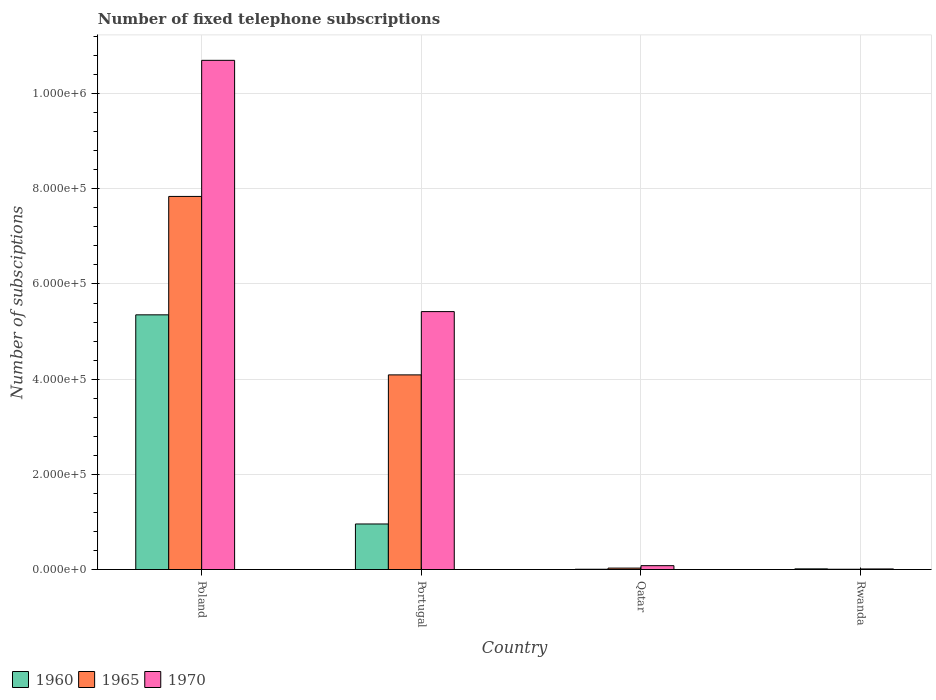How many different coloured bars are there?
Provide a succinct answer. 3. How many groups of bars are there?
Make the answer very short. 4. Are the number of bars on each tick of the X-axis equal?
Offer a terse response. Yes. How many bars are there on the 3rd tick from the right?
Provide a short and direct response. 3. What is the label of the 3rd group of bars from the left?
Your answer should be very brief. Qatar. In how many cases, is the number of bars for a given country not equal to the number of legend labels?
Provide a short and direct response. 0. What is the number of fixed telephone subscriptions in 1960 in Rwanda?
Offer a very short reply. 1366. Across all countries, what is the maximum number of fixed telephone subscriptions in 1960?
Make the answer very short. 5.35e+05. Across all countries, what is the minimum number of fixed telephone subscriptions in 1960?
Your answer should be compact. 600. In which country was the number of fixed telephone subscriptions in 1960 maximum?
Offer a very short reply. Poland. In which country was the number of fixed telephone subscriptions in 1960 minimum?
Offer a terse response. Qatar. What is the total number of fixed telephone subscriptions in 1960 in the graph?
Provide a short and direct response. 6.33e+05. What is the difference between the number of fixed telephone subscriptions in 1960 in Poland and that in Portugal?
Provide a succinct answer. 4.40e+05. What is the difference between the number of fixed telephone subscriptions in 1965 in Portugal and the number of fixed telephone subscriptions in 1960 in Rwanda?
Your response must be concise. 4.08e+05. What is the average number of fixed telephone subscriptions in 1970 per country?
Your answer should be very brief. 4.05e+05. What is the difference between the number of fixed telephone subscriptions of/in 1960 and number of fixed telephone subscriptions of/in 1965 in Qatar?
Your response must be concise. -2400. In how many countries, is the number of fixed telephone subscriptions in 1960 greater than 480000?
Provide a succinct answer. 1. What is the ratio of the number of fixed telephone subscriptions in 1965 in Portugal to that in Rwanda?
Ensure brevity in your answer.  681.67. Is the number of fixed telephone subscriptions in 1965 in Portugal less than that in Rwanda?
Provide a succinct answer. No. Is the difference between the number of fixed telephone subscriptions in 1960 in Poland and Portugal greater than the difference between the number of fixed telephone subscriptions in 1965 in Poland and Portugal?
Give a very brief answer. Yes. What is the difference between the highest and the second highest number of fixed telephone subscriptions in 1960?
Provide a short and direct response. -4.40e+05. What is the difference between the highest and the lowest number of fixed telephone subscriptions in 1965?
Your answer should be compact. 7.83e+05. What does the 1st bar from the left in Portugal represents?
Offer a very short reply. 1960. What does the 3rd bar from the right in Poland represents?
Give a very brief answer. 1960. How many bars are there?
Offer a very short reply. 12. Are all the bars in the graph horizontal?
Keep it short and to the point. No. How many countries are there in the graph?
Ensure brevity in your answer.  4. What is the difference between two consecutive major ticks on the Y-axis?
Provide a short and direct response. 2.00e+05. Does the graph contain grids?
Your response must be concise. Yes. How many legend labels are there?
Give a very brief answer. 3. What is the title of the graph?
Provide a short and direct response. Number of fixed telephone subscriptions. Does "1985" appear as one of the legend labels in the graph?
Your answer should be very brief. No. What is the label or title of the X-axis?
Your answer should be compact. Country. What is the label or title of the Y-axis?
Ensure brevity in your answer.  Number of subsciptions. What is the Number of subsciptions of 1960 in Poland?
Offer a very short reply. 5.35e+05. What is the Number of subsciptions in 1965 in Poland?
Offer a terse response. 7.84e+05. What is the Number of subsciptions of 1970 in Poland?
Your answer should be very brief. 1.07e+06. What is the Number of subsciptions of 1960 in Portugal?
Provide a succinct answer. 9.57e+04. What is the Number of subsciptions in 1965 in Portugal?
Give a very brief answer. 4.09e+05. What is the Number of subsciptions of 1970 in Portugal?
Give a very brief answer. 5.42e+05. What is the Number of subsciptions of 1960 in Qatar?
Your response must be concise. 600. What is the Number of subsciptions in 1965 in Qatar?
Provide a short and direct response. 3000. What is the Number of subsciptions in 1970 in Qatar?
Ensure brevity in your answer.  8100. What is the Number of subsciptions in 1960 in Rwanda?
Make the answer very short. 1366. What is the Number of subsciptions of 1965 in Rwanda?
Provide a short and direct response. 600. What is the Number of subsciptions of 1970 in Rwanda?
Your response must be concise. 1200. Across all countries, what is the maximum Number of subsciptions of 1960?
Your answer should be compact. 5.35e+05. Across all countries, what is the maximum Number of subsciptions of 1965?
Give a very brief answer. 7.84e+05. Across all countries, what is the maximum Number of subsciptions of 1970?
Your answer should be compact. 1.07e+06. Across all countries, what is the minimum Number of subsciptions in 1960?
Provide a short and direct response. 600. Across all countries, what is the minimum Number of subsciptions in 1965?
Provide a succinct answer. 600. Across all countries, what is the minimum Number of subsciptions in 1970?
Make the answer very short. 1200. What is the total Number of subsciptions in 1960 in the graph?
Your answer should be very brief. 6.33e+05. What is the total Number of subsciptions in 1965 in the graph?
Offer a terse response. 1.20e+06. What is the total Number of subsciptions in 1970 in the graph?
Your response must be concise. 1.62e+06. What is the difference between the Number of subsciptions in 1960 in Poland and that in Portugal?
Provide a short and direct response. 4.40e+05. What is the difference between the Number of subsciptions in 1965 in Poland and that in Portugal?
Your answer should be compact. 3.75e+05. What is the difference between the Number of subsciptions of 1970 in Poland and that in Portugal?
Your answer should be very brief. 5.28e+05. What is the difference between the Number of subsciptions of 1960 in Poland and that in Qatar?
Provide a short and direct response. 5.35e+05. What is the difference between the Number of subsciptions in 1965 in Poland and that in Qatar?
Your response must be concise. 7.81e+05. What is the difference between the Number of subsciptions in 1970 in Poland and that in Qatar?
Ensure brevity in your answer.  1.06e+06. What is the difference between the Number of subsciptions in 1960 in Poland and that in Rwanda?
Offer a terse response. 5.34e+05. What is the difference between the Number of subsciptions in 1965 in Poland and that in Rwanda?
Offer a terse response. 7.83e+05. What is the difference between the Number of subsciptions of 1970 in Poland and that in Rwanda?
Offer a terse response. 1.07e+06. What is the difference between the Number of subsciptions of 1960 in Portugal and that in Qatar?
Provide a succinct answer. 9.51e+04. What is the difference between the Number of subsciptions in 1965 in Portugal and that in Qatar?
Offer a terse response. 4.06e+05. What is the difference between the Number of subsciptions of 1970 in Portugal and that in Qatar?
Offer a very short reply. 5.34e+05. What is the difference between the Number of subsciptions in 1960 in Portugal and that in Rwanda?
Your response must be concise. 9.43e+04. What is the difference between the Number of subsciptions of 1965 in Portugal and that in Rwanda?
Make the answer very short. 4.08e+05. What is the difference between the Number of subsciptions in 1970 in Portugal and that in Rwanda?
Offer a very short reply. 5.41e+05. What is the difference between the Number of subsciptions in 1960 in Qatar and that in Rwanda?
Give a very brief answer. -766. What is the difference between the Number of subsciptions in 1965 in Qatar and that in Rwanda?
Keep it short and to the point. 2400. What is the difference between the Number of subsciptions in 1970 in Qatar and that in Rwanda?
Your response must be concise. 6900. What is the difference between the Number of subsciptions in 1960 in Poland and the Number of subsciptions in 1965 in Portugal?
Provide a short and direct response. 1.26e+05. What is the difference between the Number of subsciptions in 1960 in Poland and the Number of subsciptions in 1970 in Portugal?
Your answer should be very brief. -6798. What is the difference between the Number of subsciptions in 1965 in Poland and the Number of subsciptions in 1970 in Portugal?
Provide a succinct answer. 2.42e+05. What is the difference between the Number of subsciptions of 1960 in Poland and the Number of subsciptions of 1965 in Qatar?
Your answer should be very brief. 5.32e+05. What is the difference between the Number of subsciptions in 1960 in Poland and the Number of subsciptions in 1970 in Qatar?
Offer a terse response. 5.27e+05. What is the difference between the Number of subsciptions in 1965 in Poland and the Number of subsciptions in 1970 in Qatar?
Your answer should be compact. 7.76e+05. What is the difference between the Number of subsciptions of 1960 in Poland and the Number of subsciptions of 1965 in Rwanda?
Give a very brief answer. 5.35e+05. What is the difference between the Number of subsciptions in 1960 in Poland and the Number of subsciptions in 1970 in Rwanda?
Your response must be concise. 5.34e+05. What is the difference between the Number of subsciptions in 1965 in Poland and the Number of subsciptions in 1970 in Rwanda?
Keep it short and to the point. 7.83e+05. What is the difference between the Number of subsciptions of 1960 in Portugal and the Number of subsciptions of 1965 in Qatar?
Your response must be concise. 9.27e+04. What is the difference between the Number of subsciptions in 1960 in Portugal and the Number of subsciptions in 1970 in Qatar?
Your answer should be very brief. 8.76e+04. What is the difference between the Number of subsciptions of 1965 in Portugal and the Number of subsciptions of 1970 in Qatar?
Provide a succinct answer. 4.01e+05. What is the difference between the Number of subsciptions of 1960 in Portugal and the Number of subsciptions of 1965 in Rwanda?
Make the answer very short. 9.51e+04. What is the difference between the Number of subsciptions in 1960 in Portugal and the Number of subsciptions in 1970 in Rwanda?
Ensure brevity in your answer.  9.45e+04. What is the difference between the Number of subsciptions in 1965 in Portugal and the Number of subsciptions in 1970 in Rwanda?
Your response must be concise. 4.08e+05. What is the difference between the Number of subsciptions of 1960 in Qatar and the Number of subsciptions of 1970 in Rwanda?
Your response must be concise. -600. What is the difference between the Number of subsciptions of 1965 in Qatar and the Number of subsciptions of 1970 in Rwanda?
Your response must be concise. 1800. What is the average Number of subsciptions of 1960 per country?
Offer a terse response. 1.58e+05. What is the average Number of subsciptions of 1965 per country?
Your answer should be compact. 2.99e+05. What is the average Number of subsciptions in 1970 per country?
Make the answer very short. 4.05e+05. What is the difference between the Number of subsciptions in 1960 and Number of subsciptions in 1965 in Poland?
Your answer should be very brief. -2.49e+05. What is the difference between the Number of subsciptions in 1960 and Number of subsciptions in 1970 in Poland?
Provide a succinct answer. -5.35e+05. What is the difference between the Number of subsciptions of 1965 and Number of subsciptions of 1970 in Poland?
Offer a terse response. -2.86e+05. What is the difference between the Number of subsciptions in 1960 and Number of subsciptions in 1965 in Portugal?
Offer a very short reply. -3.13e+05. What is the difference between the Number of subsciptions in 1960 and Number of subsciptions in 1970 in Portugal?
Keep it short and to the point. -4.46e+05. What is the difference between the Number of subsciptions of 1965 and Number of subsciptions of 1970 in Portugal?
Offer a terse response. -1.33e+05. What is the difference between the Number of subsciptions of 1960 and Number of subsciptions of 1965 in Qatar?
Offer a very short reply. -2400. What is the difference between the Number of subsciptions of 1960 and Number of subsciptions of 1970 in Qatar?
Make the answer very short. -7500. What is the difference between the Number of subsciptions in 1965 and Number of subsciptions in 1970 in Qatar?
Give a very brief answer. -5100. What is the difference between the Number of subsciptions of 1960 and Number of subsciptions of 1965 in Rwanda?
Provide a succinct answer. 766. What is the difference between the Number of subsciptions of 1960 and Number of subsciptions of 1970 in Rwanda?
Your answer should be compact. 166. What is the difference between the Number of subsciptions of 1965 and Number of subsciptions of 1970 in Rwanda?
Make the answer very short. -600. What is the ratio of the Number of subsciptions in 1960 in Poland to that in Portugal?
Your answer should be very brief. 5.59. What is the ratio of the Number of subsciptions in 1965 in Poland to that in Portugal?
Offer a terse response. 1.92. What is the ratio of the Number of subsciptions in 1970 in Poland to that in Portugal?
Make the answer very short. 1.97. What is the ratio of the Number of subsciptions in 1960 in Poland to that in Qatar?
Your answer should be very brief. 892. What is the ratio of the Number of subsciptions in 1965 in Poland to that in Qatar?
Provide a short and direct response. 261.33. What is the ratio of the Number of subsciptions in 1970 in Poland to that in Qatar?
Make the answer very short. 132.1. What is the ratio of the Number of subsciptions in 1960 in Poland to that in Rwanda?
Ensure brevity in your answer.  391.8. What is the ratio of the Number of subsciptions of 1965 in Poland to that in Rwanda?
Provide a succinct answer. 1306.67. What is the ratio of the Number of subsciptions in 1970 in Poland to that in Rwanda?
Ensure brevity in your answer.  891.67. What is the ratio of the Number of subsciptions in 1960 in Portugal to that in Qatar?
Provide a succinct answer. 159.5. What is the ratio of the Number of subsciptions of 1965 in Portugal to that in Qatar?
Your answer should be compact. 136.33. What is the ratio of the Number of subsciptions of 1970 in Portugal to that in Qatar?
Make the answer very short. 66.91. What is the ratio of the Number of subsciptions of 1960 in Portugal to that in Rwanda?
Provide a short and direct response. 70.06. What is the ratio of the Number of subsciptions of 1965 in Portugal to that in Rwanda?
Ensure brevity in your answer.  681.67. What is the ratio of the Number of subsciptions of 1970 in Portugal to that in Rwanda?
Provide a succinct answer. 451.67. What is the ratio of the Number of subsciptions of 1960 in Qatar to that in Rwanda?
Your answer should be compact. 0.44. What is the ratio of the Number of subsciptions in 1970 in Qatar to that in Rwanda?
Ensure brevity in your answer.  6.75. What is the difference between the highest and the second highest Number of subsciptions of 1960?
Make the answer very short. 4.40e+05. What is the difference between the highest and the second highest Number of subsciptions in 1965?
Offer a terse response. 3.75e+05. What is the difference between the highest and the second highest Number of subsciptions in 1970?
Offer a terse response. 5.28e+05. What is the difference between the highest and the lowest Number of subsciptions of 1960?
Provide a succinct answer. 5.35e+05. What is the difference between the highest and the lowest Number of subsciptions in 1965?
Offer a very short reply. 7.83e+05. What is the difference between the highest and the lowest Number of subsciptions of 1970?
Give a very brief answer. 1.07e+06. 